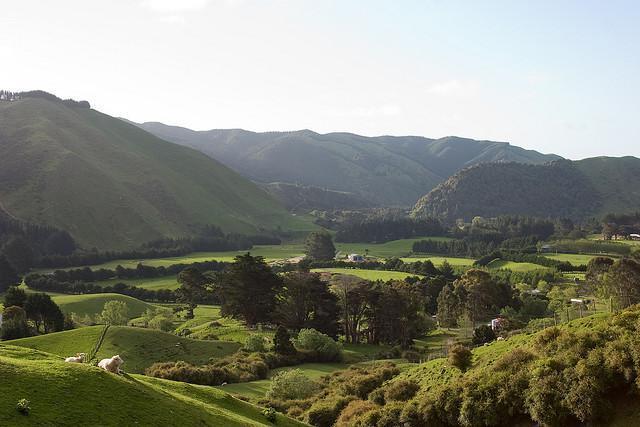How many roads are there?
Give a very brief answer. 0. How many people are shown?
Give a very brief answer. 0. 